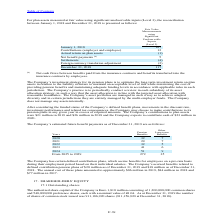According to Stmicroelectronics's financial document, What was the annual cost of contribution pension plans in 2019? According to the financial document, $86 million. The relevant text states: "nual cost of these plans amounted to approximately $86 million in 2019, $84 million in 2018 and $77 million in 2017...." Also, What was the annual cost of contribution pension plans in 2018? According to the financial document, $84 million. The relevant text states: "ans amounted to approximately $86 million in 2019, $84 million in 2018 and $77 million in 2017...." Also, What was the annual cost of contribution pension plans in 2017? According to the financial document, $77 million. The relevant text states: "ately $86 million in 2019, $84 million in 2018 and $77 million in 2017...." Also, can you calculate: What is the average benefit payments for 2020 to 2021? To answer this question, I need to perform calculations using the financial data. The calculation is: (32+29) / 2, which equals 30.5 (in millions). This is based on the information: "2021 29 7 2020 32 7..." The key data points involved are: 29, 32. Also, can you calculate: What is the average benefit payments for 2021 to 2022? To answer this question, I need to perform calculations using the financial data. The calculation is: (29+32) / 2, which equals 30.5 (in millions). This is based on the information: "2021 29 7 2020 32 7..." The key data points involved are: 29, 32. Also, can you calculate: What is the average benefit payments for 2022 to 2023? To answer this question, I need to perform calculations using the financial data. The calculation is: (32+41) / 2, which equals 36.5 (in millions). This is based on the information: "2023 41 6 2020 32 7..." The key data points involved are: 32, 41. 